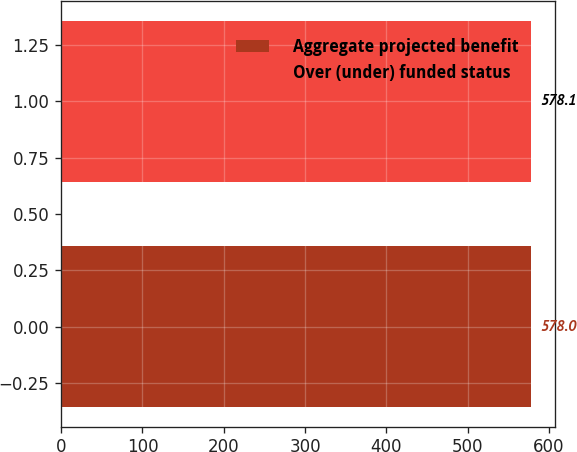Convert chart. <chart><loc_0><loc_0><loc_500><loc_500><bar_chart><fcel>Aggregate projected benefit<fcel>Over (under) funded status<nl><fcel>578<fcel>578.1<nl></chart> 